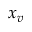Convert formula to latex. <formula><loc_0><loc_0><loc_500><loc_500>x _ { v }</formula> 